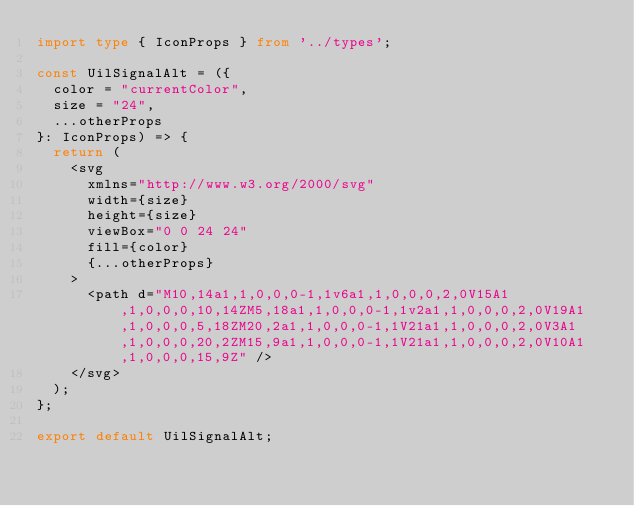Convert code to text. <code><loc_0><loc_0><loc_500><loc_500><_TypeScript_>import type { IconProps } from '../types';

const UilSignalAlt = ({
  color = "currentColor",
  size = "24",
  ...otherProps
}: IconProps) => {
  return (
    <svg
      xmlns="http://www.w3.org/2000/svg"
      width={size}
      height={size}
      viewBox="0 0 24 24"
      fill={color}
      {...otherProps}
    >
      <path d="M10,14a1,1,0,0,0-1,1v6a1,1,0,0,0,2,0V15A1,1,0,0,0,10,14ZM5,18a1,1,0,0,0-1,1v2a1,1,0,0,0,2,0V19A1,1,0,0,0,5,18ZM20,2a1,1,0,0,0-1,1V21a1,1,0,0,0,2,0V3A1,1,0,0,0,20,2ZM15,9a1,1,0,0,0-1,1V21a1,1,0,0,0,2,0V10A1,1,0,0,0,15,9Z" />
    </svg>
  );
};

export default UilSignalAlt;</code> 